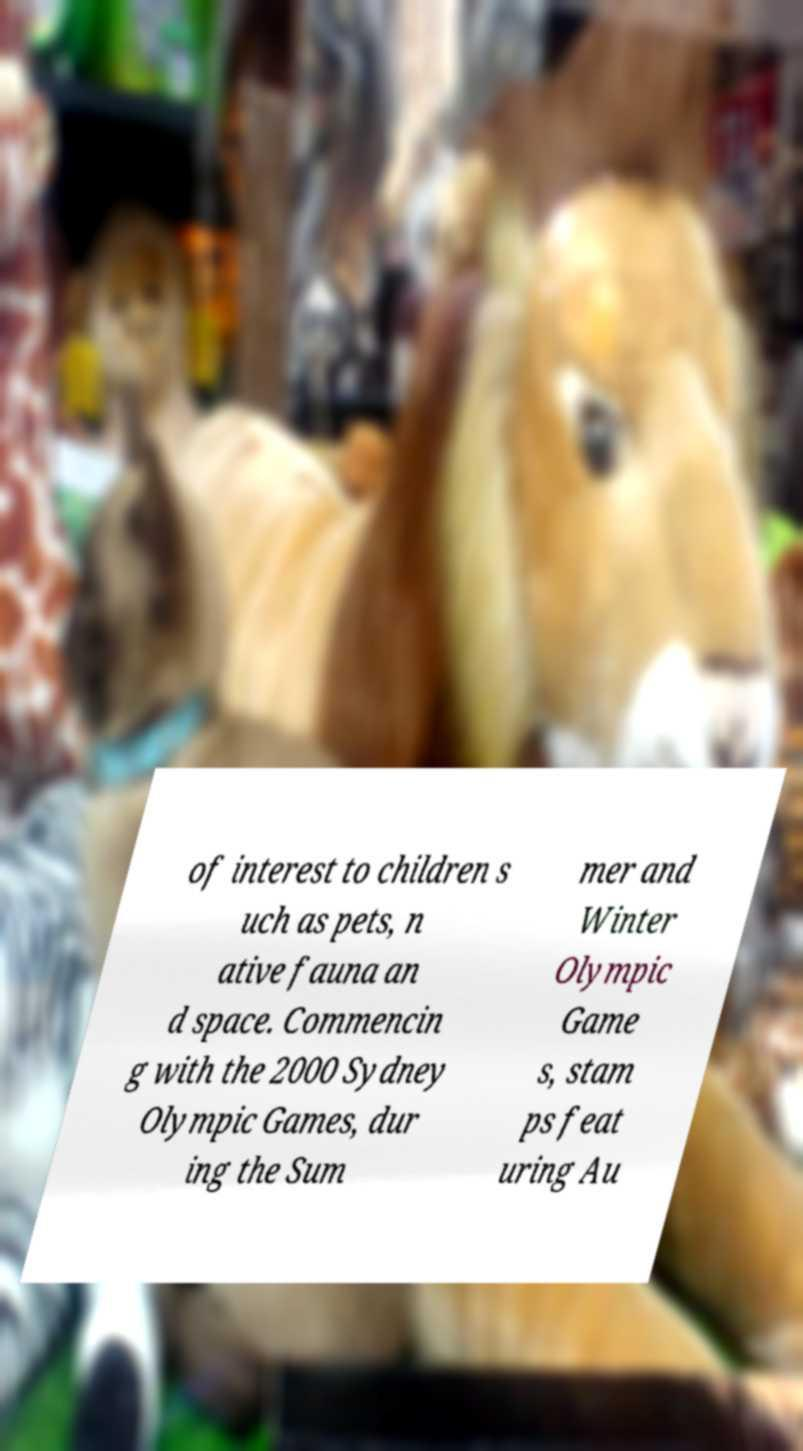Can you read and provide the text displayed in the image?This photo seems to have some interesting text. Can you extract and type it out for me? of interest to children s uch as pets, n ative fauna an d space. Commencin g with the 2000 Sydney Olympic Games, dur ing the Sum mer and Winter Olympic Game s, stam ps feat uring Au 